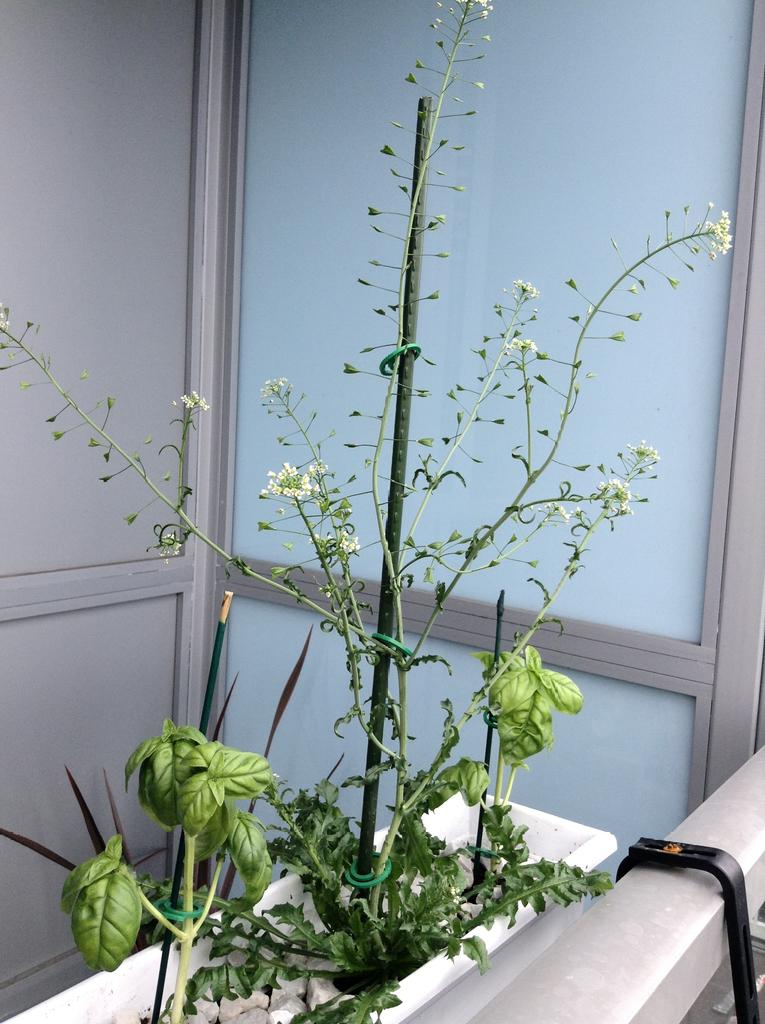What object is visible in the image? There is a plant pot in the image. Where is the plant pot located? The plant pot is located in the balcony of a building. What type of payment is being made in the image? There is no payment being made in the image; it only features a plant pot on a balcony. What kind of flowers are growing in the plant pot? There is no information about flowers in the image; it only shows a plant pot. 